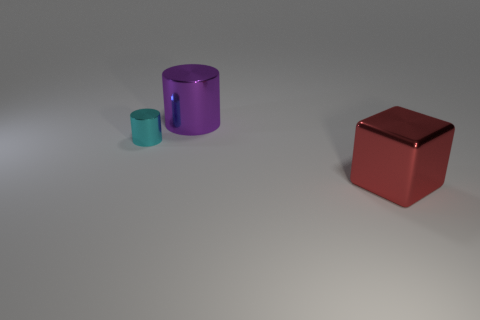What is the material of the thing that is left of the big metallic object left of the metal object that is right of the purple shiny cylinder?
Provide a succinct answer. Metal. How many objects are either tiny red matte objects or cylinders?
Make the answer very short. 2. Are there any other things that are made of the same material as the red cube?
Your response must be concise. Yes. What is the shape of the tiny cyan shiny object?
Offer a very short reply. Cylinder. What is the shape of the large shiny thing that is behind the big object that is in front of the cyan metallic object?
Offer a terse response. Cylinder. Is the material of the object behind the cyan metallic thing the same as the red thing?
Make the answer very short. Yes. What number of cyan objects are large objects or large cylinders?
Your answer should be compact. 0. Is there a big shiny cylinder of the same color as the big block?
Your answer should be very brief. No. Are there any cyan objects made of the same material as the large red object?
Offer a terse response. Yes. There is a thing that is to the left of the cube and right of the cyan metal object; what shape is it?
Offer a terse response. Cylinder. 